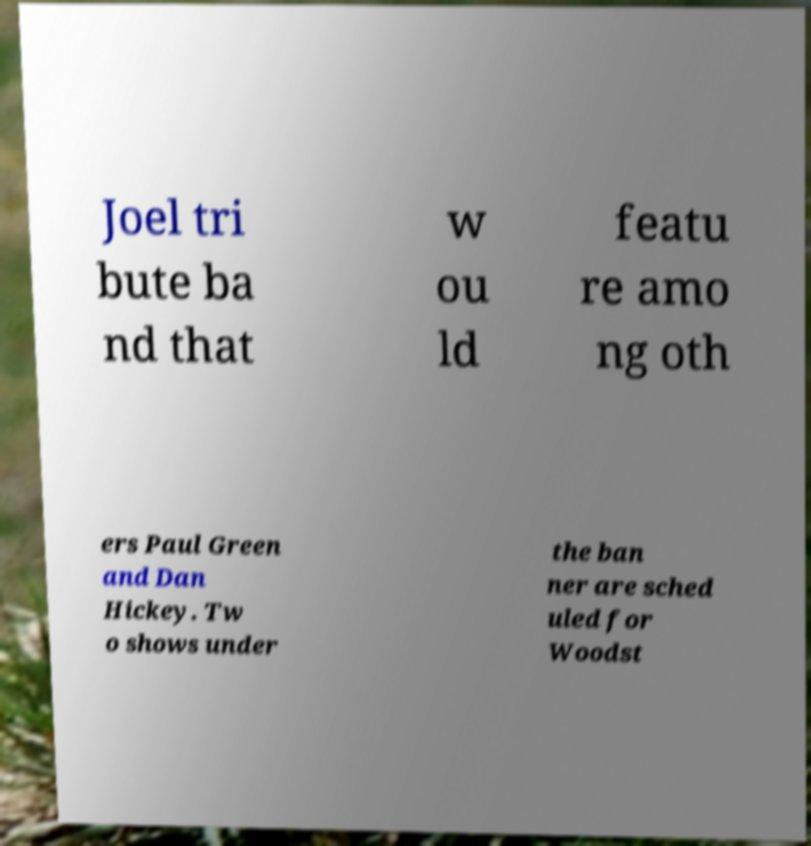Can you accurately transcribe the text from the provided image for me? Joel tri bute ba nd that w ou ld featu re amo ng oth ers Paul Green and Dan Hickey. Tw o shows under the ban ner are sched uled for Woodst 